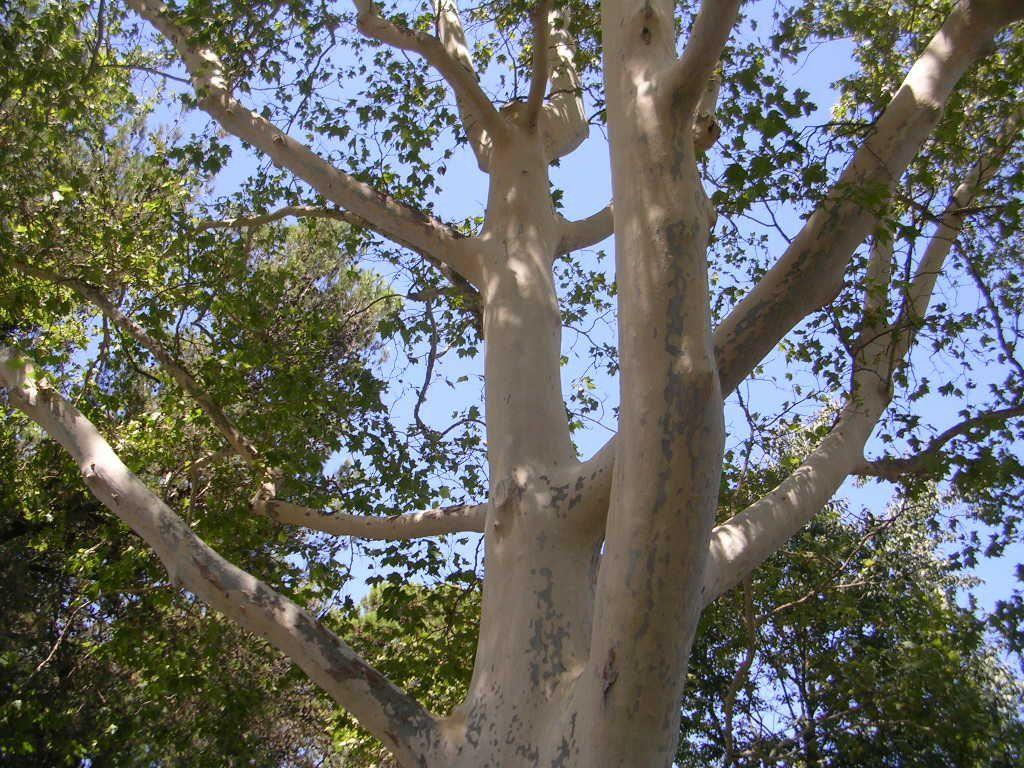What type of vegetation can be seen in the image? There are trees in the image. What is visible behind the trees in the image? The sky is visible behind the trees in the image. Where is the chair located in the image? There is no chair present in the image. Can you see any smoke coming from the trees in the image? There is no smoke visible in the image. 